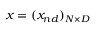Convert formula to latex. <formula><loc_0><loc_0><loc_500><loc_500>x = ( x _ { n d } ) _ { N \times { D } }</formula> 